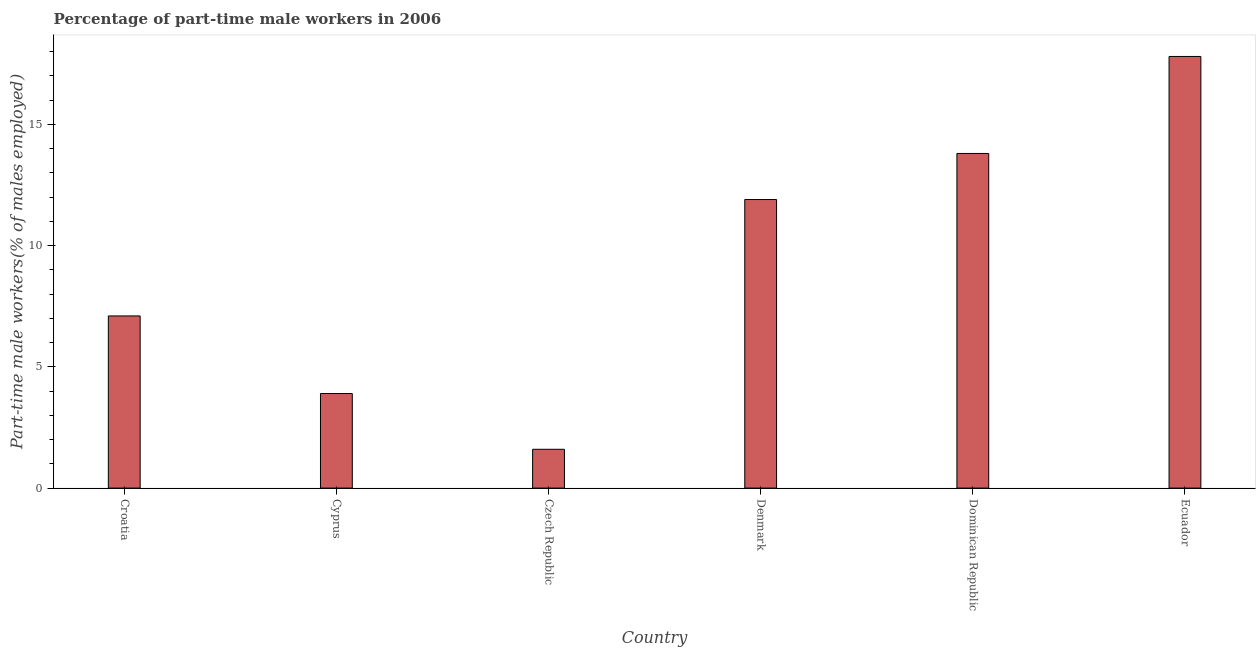What is the title of the graph?
Give a very brief answer. Percentage of part-time male workers in 2006. What is the label or title of the Y-axis?
Keep it short and to the point. Part-time male workers(% of males employed). What is the percentage of part-time male workers in Denmark?
Give a very brief answer. 11.9. Across all countries, what is the maximum percentage of part-time male workers?
Give a very brief answer. 17.8. Across all countries, what is the minimum percentage of part-time male workers?
Your response must be concise. 1.6. In which country was the percentage of part-time male workers maximum?
Offer a terse response. Ecuador. In which country was the percentage of part-time male workers minimum?
Give a very brief answer. Czech Republic. What is the sum of the percentage of part-time male workers?
Give a very brief answer. 56.1. What is the difference between the percentage of part-time male workers in Cyprus and Denmark?
Your answer should be compact. -8. What is the average percentage of part-time male workers per country?
Provide a succinct answer. 9.35. What is the median percentage of part-time male workers?
Make the answer very short. 9.5. In how many countries, is the percentage of part-time male workers greater than 14 %?
Give a very brief answer. 1. What is the ratio of the percentage of part-time male workers in Croatia to that in Denmark?
Give a very brief answer. 0.6. What is the difference between the highest and the second highest percentage of part-time male workers?
Your response must be concise. 4. What is the difference between the highest and the lowest percentage of part-time male workers?
Give a very brief answer. 16.2. In how many countries, is the percentage of part-time male workers greater than the average percentage of part-time male workers taken over all countries?
Your answer should be compact. 3. How many bars are there?
Give a very brief answer. 6. What is the Part-time male workers(% of males employed) of Croatia?
Ensure brevity in your answer.  7.1. What is the Part-time male workers(% of males employed) in Cyprus?
Offer a very short reply. 3.9. What is the Part-time male workers(% of males employed) of Czech Republic?
Your answer should be compact. 1.6. What is the Part-time male workers(% of males employed) of Denmark?
Ensure brevity in your answer.  11.9. What is the Part-time male workers(% of males employed) in Dominican Republic?
Keep it short and to the point. 13.8. What is the Part-time male workers(% of males employed) of Ecuador?
Provide a succinct answer. 17.8. What is the difference between the Part-time male workers(% of males employed) in Croatia and Czech Republic?
Offer a very short reply. 5.5. What is the difference between the Part-time male workers(% of males employed) in Croatia and Ecuador?
Give a very brief answer. -10.7. What is the difference between the Part-time male workers(% of males employed) in Cyprus and Denmark?
Offer a terse response. -8. What is the difference between the Part-time male workers(% of males employed) in Cyprus and Dominican Republic?
Offer a very short reply. -9.9. What is the difference between the Part-time male workers(% of males employed) in Czech Republic and Ecuador?
Your response must be concise. -16.2. What is the difference between the Part-time male workers(% of males employed) in Denmark and Dominican Republic?
Offer a very short reply. -1.9. What is the difference between the Part-time male workers(% of males employed) in Dominican Republic and Ecuador?
Provide a short and direct response. -4. What is the ratio of the Part-time male workers(% of males employed) in Croatia to that in Cyprus?
Offer a terse response. 1.82. What is the ratio of the Part-time male workers(% of males employed) in Croatia to that in Czech Republic?
Provide a short and direct response. 4.44. What is the ratio of the Part-time male workers(% of males employed) in Croatia to that in Denmark?
Make the answer very short. 0.6. What is the ratio of the Part-time male workers(% of males employed) in Croatia to that in Dominican Republic?
Your answer should be very brief. 0.51. What is the ratio of the Part-time male workers(% of males employed) in Croatia to that in Ecuador?
Offer a terse response. 0.4. What is the ratio of the Part-time male workers(% of males employed) in Cyprus to that in Czech Republic?
Ensure brevity in your answer.  2.44. What is the ratio of the Part-time male workers(% of males employed) in Cyprus to that in Denmark?
Make the answer very short. 0.33. What is the ratio of the Part-time male workers(% of males employed) in Cyprus to that in Dominican Republic?
Offer a very short reply. 0.28. What is the ratio of the Part-time male workers(% of males employed) in Cyprus to that in Ecuador?
Offer a very short reply. 0.22. What is the ratio of the Part-time male workers(% of males employed) in Czech Republic to that in Denmark?
Provide a short and direct response. 0.13. What is the ratio of the Part-time male workers(% of males employed) in Czech Republic to that in Dominican Republic?
Your answer should be very brief. 0.12. What is the ratio of the Part-time male workers(% of males employed) in Czech Republic to that in Ecuador?
Provide a short and direct response. 0.09. What is the ratio of the Part-time male workers(% of males employed) in Denmark to that in Dominican Republic?
Provide a short and direct response. 0.86. What is the ratio of the Part-time male workers(% of males employed) in Denmark to that in Ecuador?
Offer a terse response. 0.67. What is the ratio of the Part-time male workers(% of males employed) in Dominican Republic to that in Ecuador?
Your answer should be compact. 0.78. 